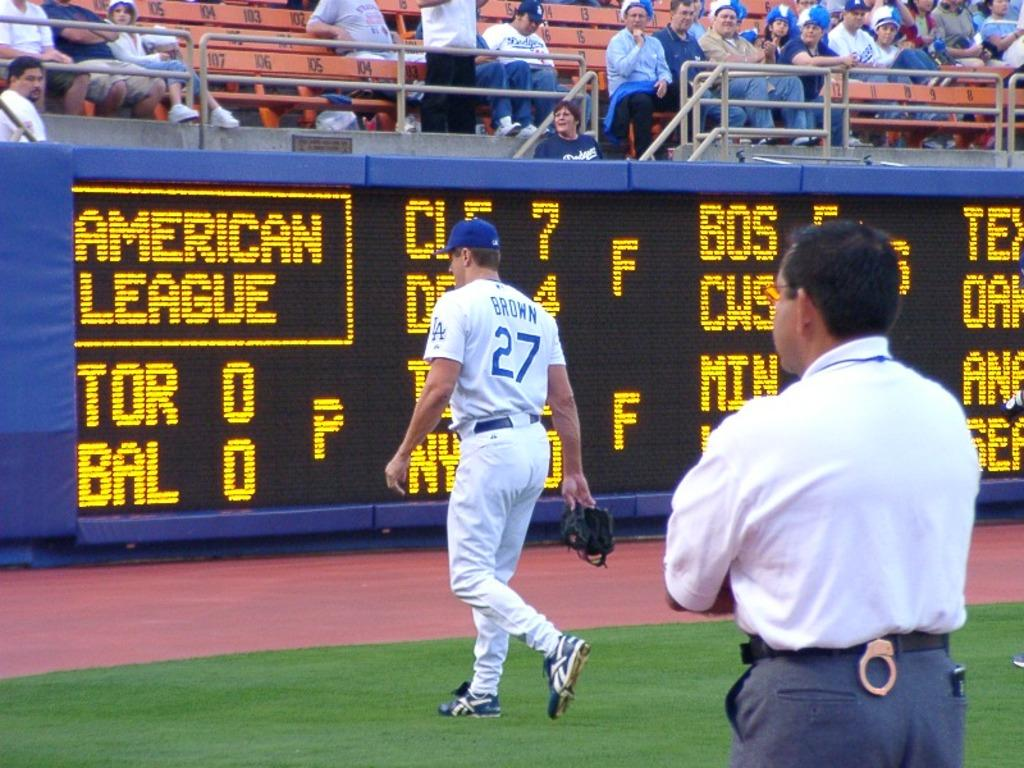Provide a one-sentence caption for the provided image. A baseball player wearing the 27 jersey walking down the field. 